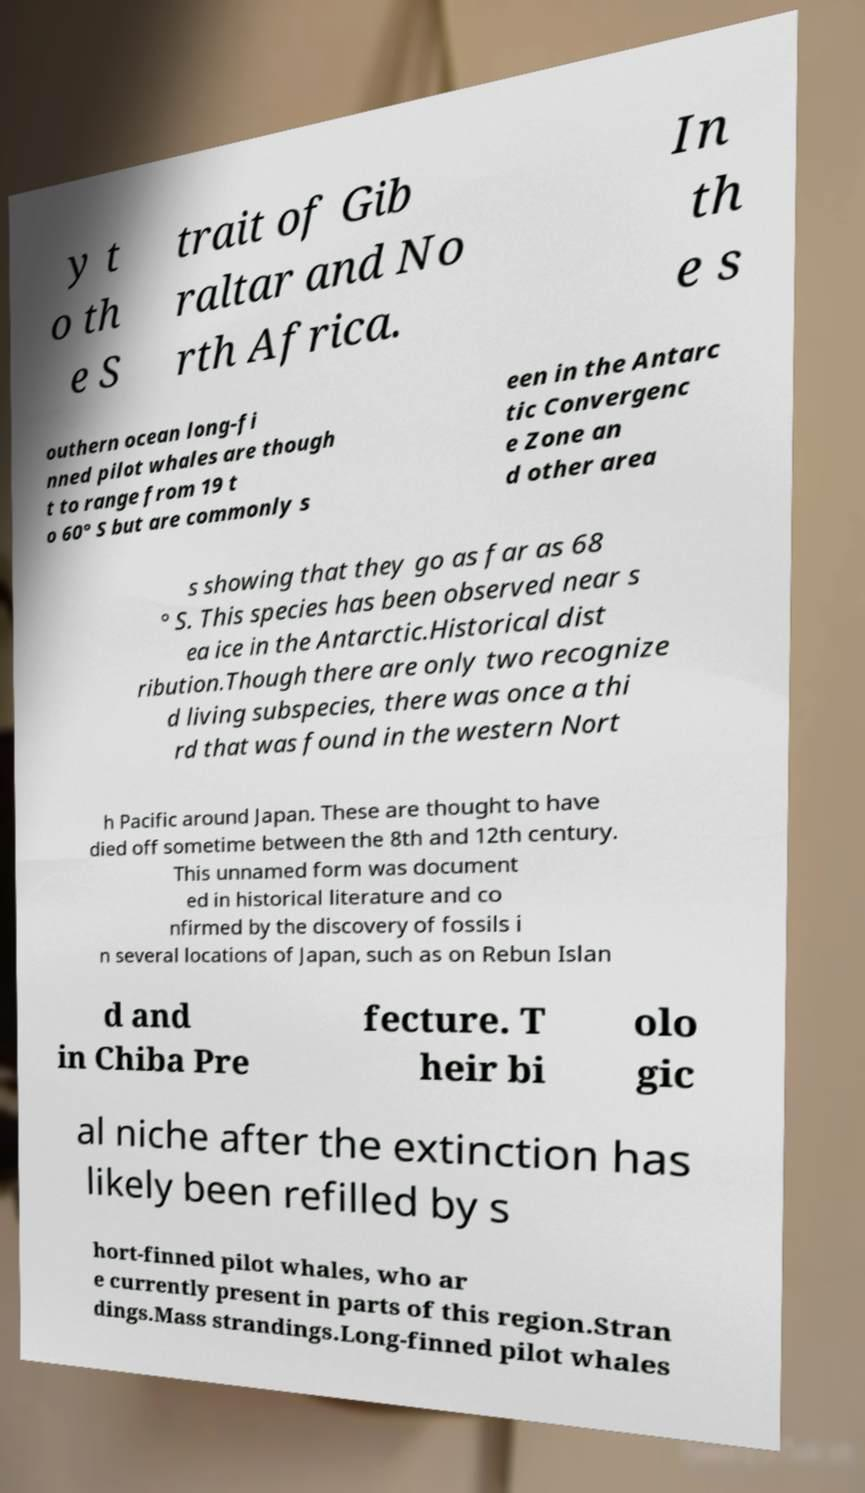For documentation purposes, I need the text within this image transcribed. Could you provide that? y t o th e S trait of Gib raltar and No rth Africa. In th e s outhern ocean long-fi nned pilot whales are though t to range from 19 t o 60° S but are commonly s een in the Antarc tic Convergenc e Zone an d other area s showing that they go as far as 68 ° S. This species has been observed near s ea ice in the Antarctic.Historical dist ribution.Though there are only two recognize d living subspecies, there was once a thi rd that was found in the western Nort h Pacific around Japan. These are thought to have died off sometime between the 8th and 12th century. This unnamed form was document ed in historical literature and co nfirmed by the discovery of fossils i n several locations of Japan, such as on Rebun Islan d and in Chiba Pre fecture. T heir bi olo gic al niche after the extinction has likely been refilled by s hort-finned pilot whales, who ar e currently present in parts of this region.Stran dings.Mass strandings.Long-finned pilot whales 